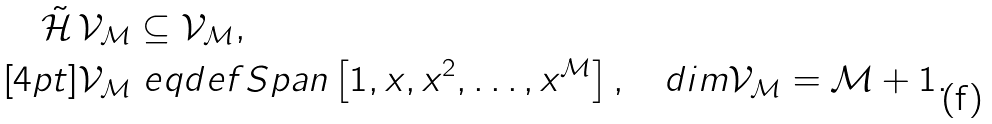Convert formula to latex. <formula><loc_0><loc_0><loc_500><loc_500>\tilde { \mathcal { H } } \, { \mathcal { V } } _ { \mathcal { M } } & \subseteq { \mathcal { V } } _ { \mathcal { M } } , \\ [ 4 p t ] { \mathcal { V } } _ { \mathcal { M } } & \ e q d e f S p a n \left [ 1 , x , x ^ { 2 } , \dots , x ^ { \mathcal { M } } \right ] , \quad d i m { \mathcal { V } } _ { \mathcal { M } } = { \mathcal { M } } + 1 .</formula> 